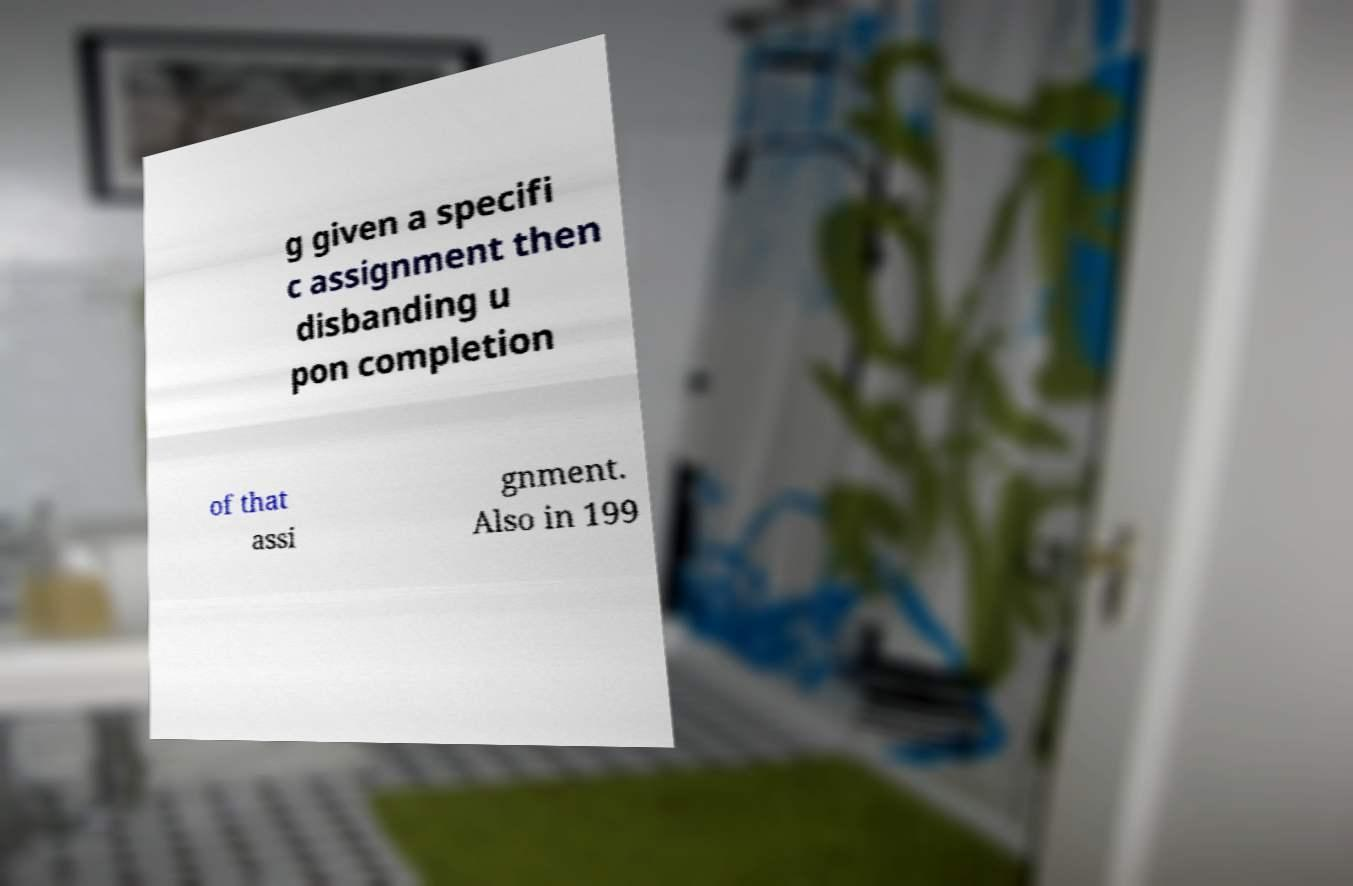For documentation purposes, I need the text within this image transcribed. Could you provide that? g given a specifi c assignment then disbanding u pon completion of that assi gnment. Also in 199 